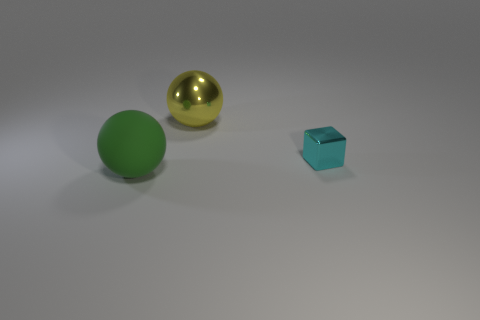There is a ball in front of the small shiny block; does it have the same color as the large shiny thing?
Make the answer very short. No. How many things are matte balls or balls that are behind the cyan block?
Your answer should be very brief. 2. What material is the object that is right of the green matte object and left of the cyan metallic thing?
Offer a terse response. Metal. There is a object that is in front of the small cyan shiny object; what is it made of?
Your response must be concise. Rubber. What color is the other big thing that is the same material as the cyan object?
Your response must be concise. Yellow. There is a big green rubber object; is it the same shape as the metal thing that is in front of the yellow ball?
Your response must be concise. No. Are there any large yellow shiny balls to the right of the yellow metal ball?
Keep it short and to the point. No. Is the size of the green matte thing the same as the thing that is on the right side of the yellow object?
Give a very brief answer. No. Is there a tiny matte object of the same color as the big matte thing?
Offer a very short reply. No. Are there any big brown matte things that have the same shape as the large green rubber thing?
Provide a short and direct response. No. 